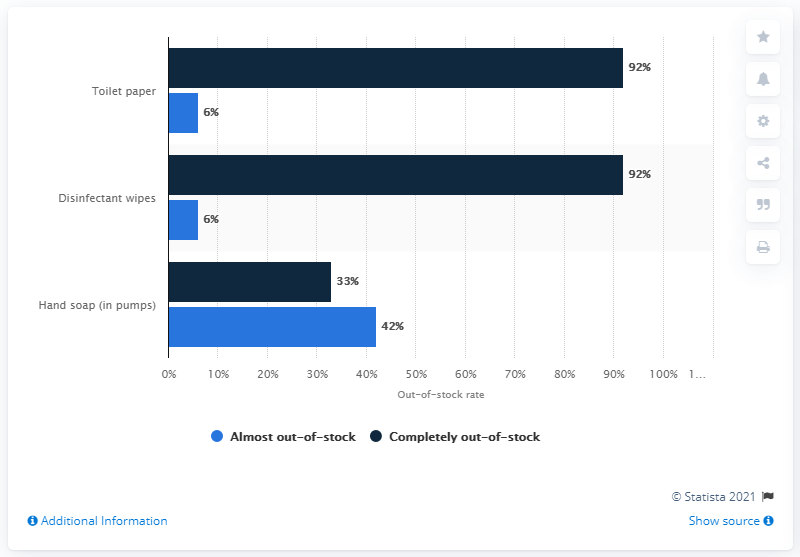Highlight a few significant elements in this photo. A total of 92% of selected retail stores surveyed as of March 19, 2020 were found to be completely out of stock of toilet paper and disinfectant wipes. 